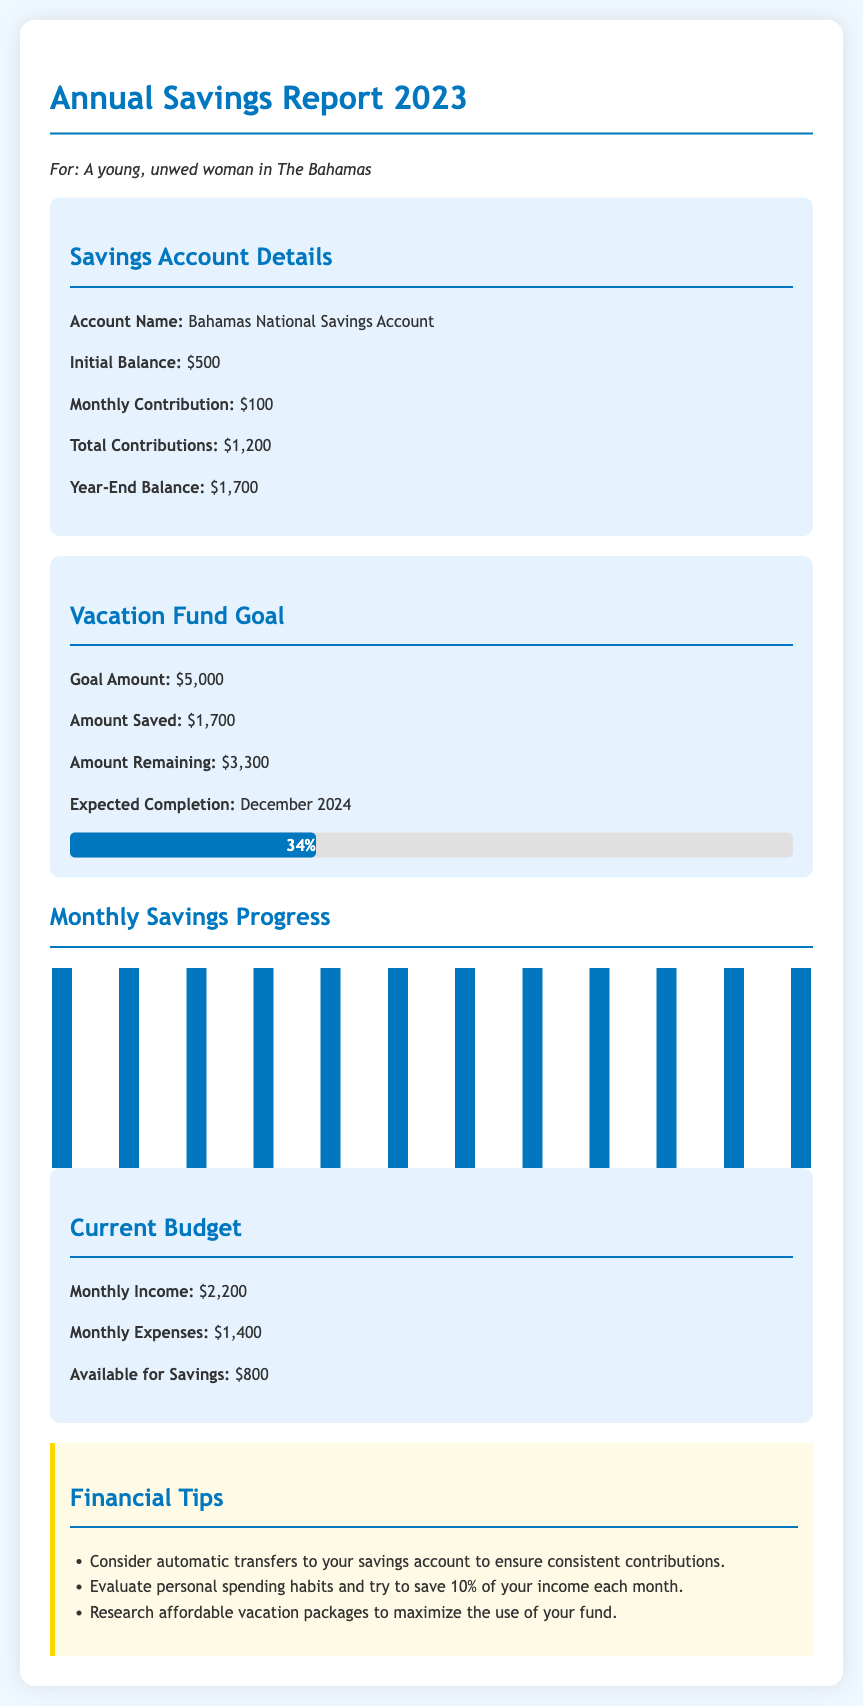What is the initial balance of the savings account? The initial balance is stated directly in the savings account details section as $500.
Answer: $500 What is the total amount saved for the vacation fund? The amount saved is mentioned in the vacation fund goal section as $1,700.
Answer: $1,700 How much is remaining to reach the vacation fund goal? The amount remaining is also given directly in the vacation fund goal section as $3,300.
Answer: $3,300 What is the expected completion date for the vacation fund? The expected completion date is provided in the vacation fund goal section as December 2024.
Answer: December 2024 What is the monthly income listed in the current budget? The monthly income is clearly mentioned in the current budget section as $2,200.
Answer: $2,200 What percentage of the vacation fund goal has been achieved? The percentage achieved is calculated and stated as 34% in the vacation fund goal section.
Answer: 34% How many months are consistently contributed to the savings account? The document shows that $100 is contributed every month across all 12 months of the year.
Answer: 12 months What is the budget available for savings each month? The available amount for savings is specified in the current budget section as $800.
Answer: $800 What financial tip suggests evaluating personal spending habits? The second tip in the financial tips section mentions evaluating spending habits to save 10% of income.
Answer: Evaluate personal spending habits 